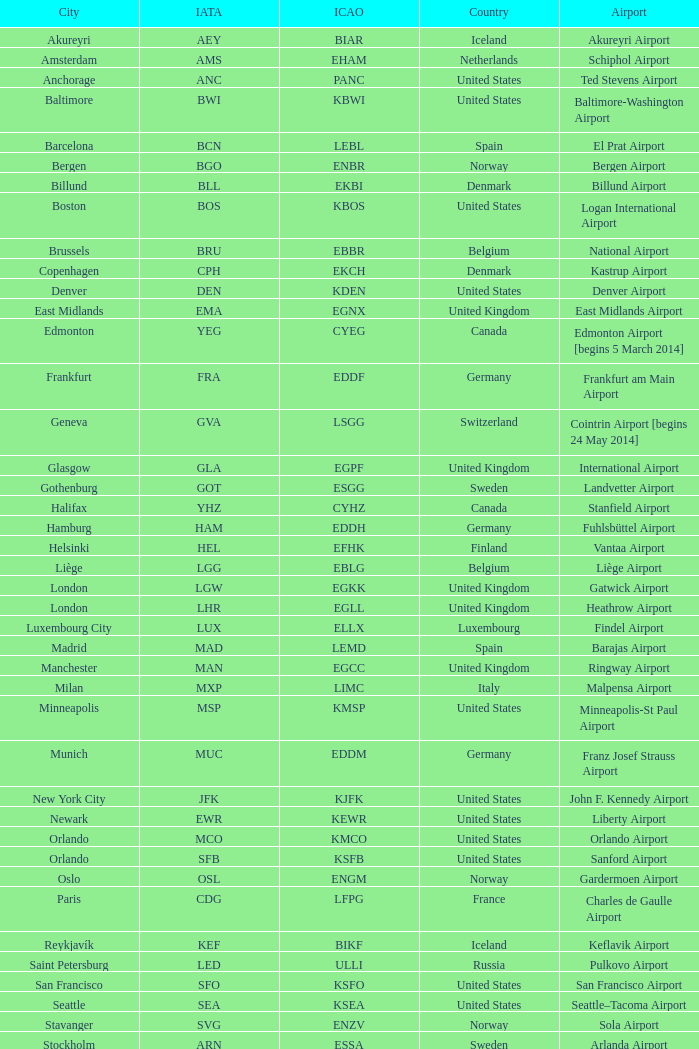What is the Airport with a ICAO of EDDH? Fuhlsbüttel Airport. 